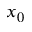Convert formula to latex. <formula><loc_0><loc_0><loc_500><loc_500>x _ { 0 }</formula> 